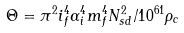Convert formula to latex. <formula><loc_0><loc_0><loc_500><loc_500>\Theta = \pi ^ { 2 } i _ { f } ^ { 4 } \alpha _ { i } ^ { 4 } m _ { f } ^ { 4 } N _ { s d } ^ { 2 } / 1 0 ^ { 6 1 } \rho _ { c }</formula> 